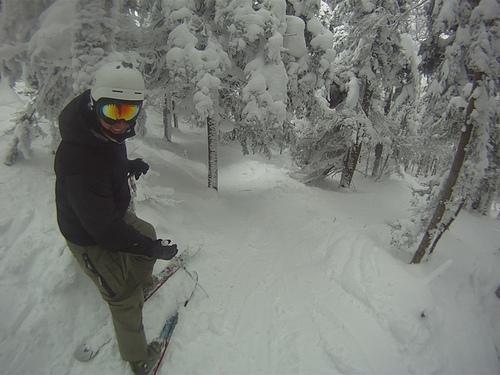How many people are in the photo?
Give a very brief answer. 1. 